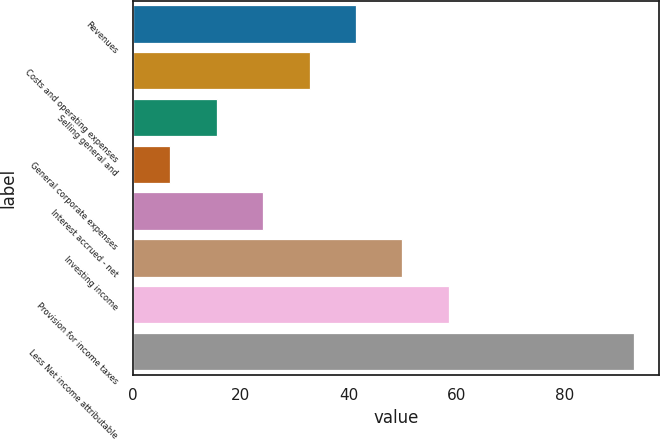Convert chart. <chart><loc_0><loc_0><loc_500><loc_500><bar_chart><fcel>Revenues<fcel>Costs and operating expenses<fcel>Selling general and<fcel>General corporate expenses<fcel>Interest accrued - net<fcel>Investing income<fcel>Provision for income taxes<fcel>Less Net income attributable<nl><fcel>41.4<fcel>32.8<fcel>15.6<fcel>7<fcel>24.2<fcel>50<fcel>58.6<fcel>93<nl></chart> 